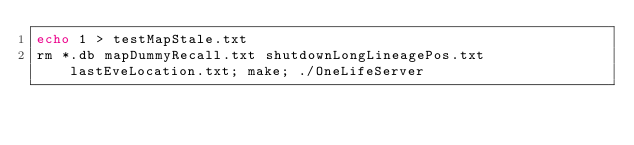Convert code to text. <code><loc_0><loc_0><loc_500><loc_500><_Bash_>echo 1 > testMapStale.txt
rm *.db mapDummyRecall.txt shutdownLongLineagePos.txt lastEveLocation.txt; make; ./OneLifeServer

</code> 